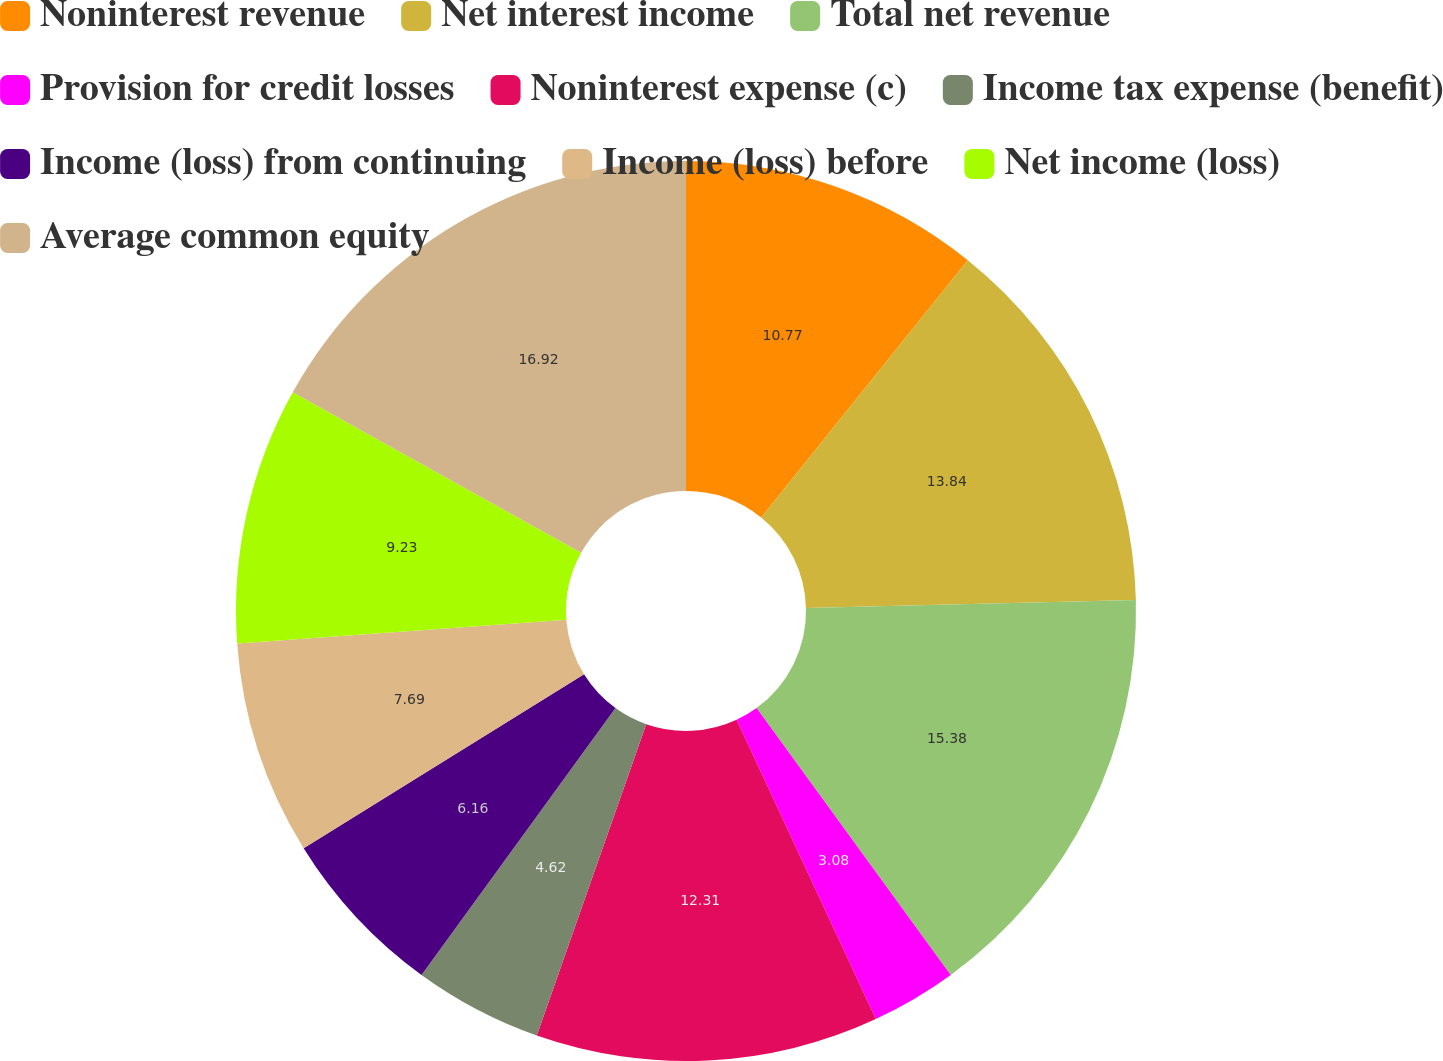Convert chart to OTSL. <chart><loc_0><loc_0><loc_500><loc_500><pie_chart><fcel>Noninterest revenue<fcel>Net interest income<fcel>Total net revenue<fcel>Provision for credit losses<fcel>Noninterest expense (c)<fcel>Income tax expense (benefit)<fcel>Income (loss) from continuing<fcel>Income (loss) before<fcel>Net income (loss)<fcel>Average common equity<nl><fcel>10.77%<fcel>13.84%<fcel>15.38%<fcel>3.08%<fcel>12.31%<fcel>4.62%<fcel>6.16%<fcel>7.69%<fcel>9.23%<fcel>16.92%<nl></chart> 